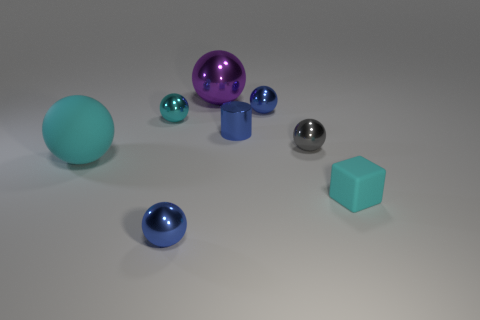There is a large cyan sphere; are there any spheres in front of it?
Provide a succinct answer. Yes. How many other objects are the same shape as the big matte object?
Your answer should be very brief. 5. The object that is the same size as the cyan matte sphere is what color?
Offer a very short reply. Purple. Is the number of small blue objects on the right side of the tiny gray metallic thing less than the number of cyan things that are behind the purple shiny object?
Give a very brief answer. No. There is a small blue object that is to the left of the big thing behind the big cyan thing; what number of small blue things are in front of it?
Provide a succinct answer. 0. The rubber thing that is the same shape as the big metallic thing is what size?
Your answer should be compact. Large. Are there fewer tiny cubes behind the gray ball than tiny brown rubber things?
Offer a very short reply. No. Does the purple metallic object have the same shape as the big rubber thing?
Your response must be concise. Yes. What is the color of the other big thing that is the same shape as the big cyan matte object?
Your answer should be very brief. Purple. How many tiny cubes are the same color as the small rubber object?
Your response must be concise. 0. 